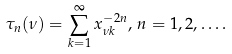Convert formula to latex. <formula><loc_0><loc_0><loc_500><loc_500>\tau _ { n } ( \nu ) = \sum _ { k = 1 } ^ { \infty } x _ { \nu k } ^ { - 2 n } , \, n = 1 , 2 , \dots .</formula> 